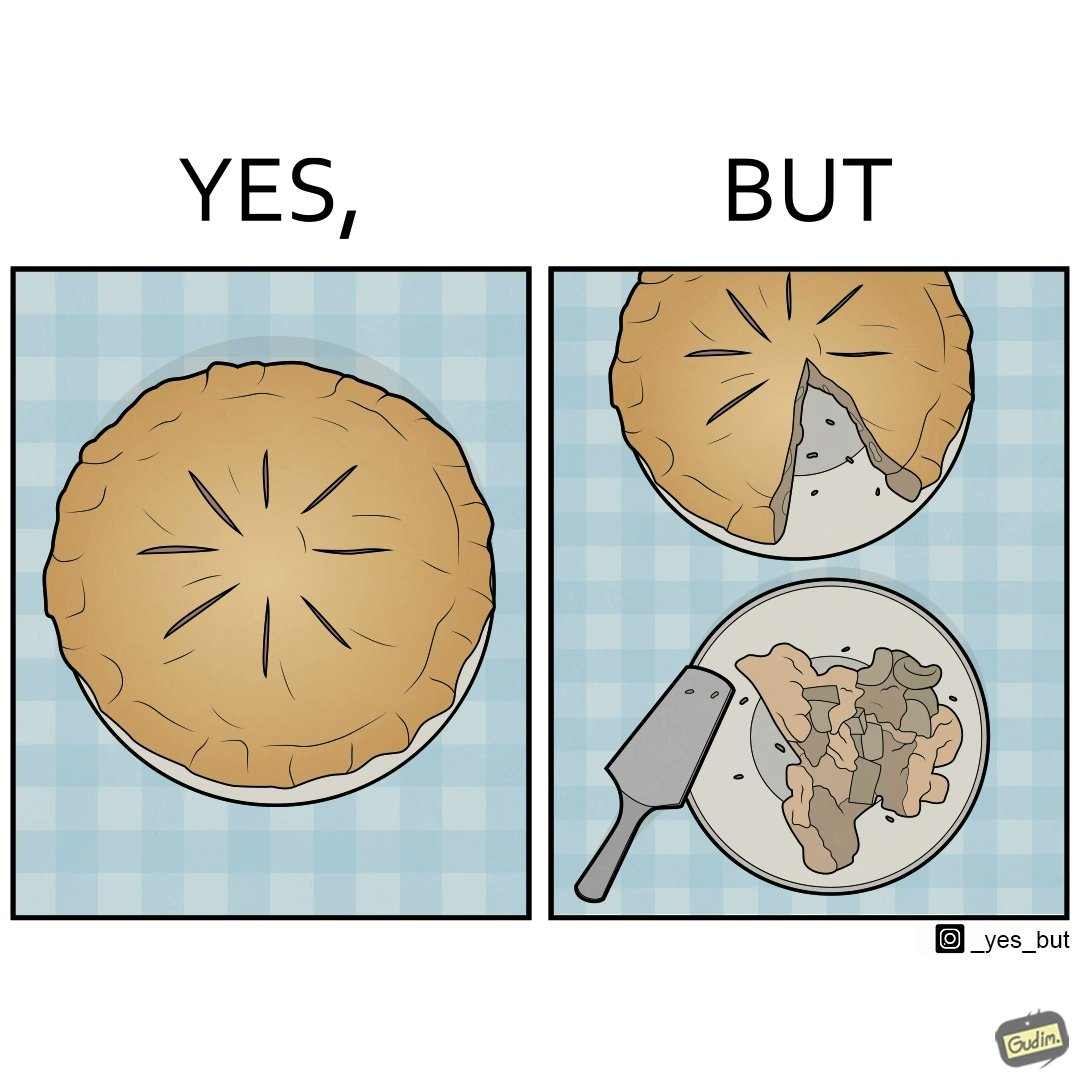Does this image contain satire or humor? Yes, this image is satirical. 